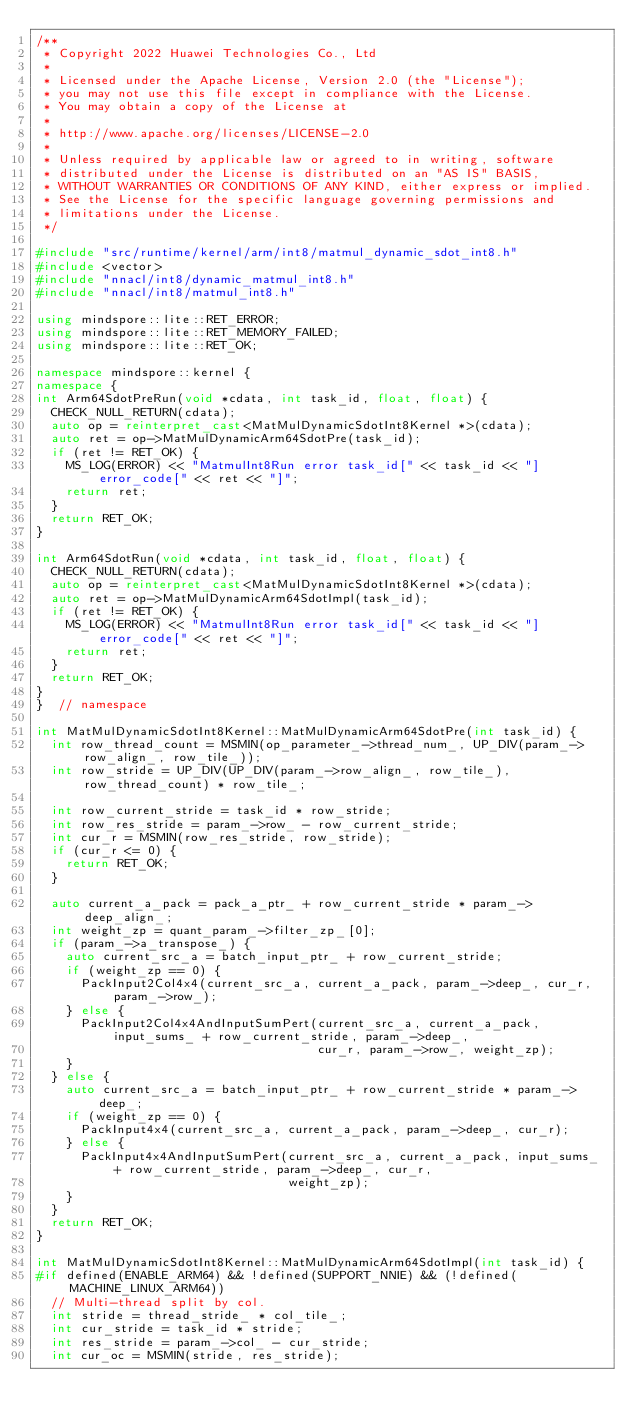Convert code to text. <code><loc_0><loc_0><loc_500><loc_500><_C++_>/**
 * Copyright 2022 Huawei Technologies Co., Ltd
 *
 * Licensed under the Apache License, Version 2.0 (the "License");
 * you may not use this file except in compliance with the License.
 * You may obtain a copy of the License at
 *
 * http://www.apache.org/licenses/LICENSE-2.0
 *
 * Unless required by applicable law or agreed to in writing, software
 * distributed under the License is distributed on an "AS IS" BASIS,
 * WITHOUT WARRANTIES OR CONDITIONS OF ANY KIND, either express or implied.
 * See the License for the specific language governing permissions and
 * limitations under the License.
 */

#include "src/runtime/kernel/arm/int8/matmul_dynamic_sdot_int8.h"
#include <vector>
#include "nnacl/int8/dynamic_matmul_int8.h"
#include "nnacl/int8/matmul_int8.h"

using mindspore::lite::RET_ERROR;
using mindspore::lite::RET_MEMORY_FAILED;
using mindspore::lite::RET_OK;

namespace mindspore::kernel {
namespace {
int Arm64SdotPreRun(void *cdata, int task_id, float, float) {
  CHECK_NULL_RETURN(cdata);
  auto op = reinterpret_cast<MatMulDynamicSdotInt8Kernel *>(cdata);
  auto ret = op->MatMulDynamicArm64SdotPre(task_id);
  if (ret != RET_OK) {
    MS_LOG(ERROR) << "MatmulInt8Run error task_id[" << task_id << "] error_code[" << ret << "]";
    return ret;
  }
  return RET_OK;
}

int Arm64SdotRun(void *cdata, int task_id, float, float) {
  CHECK_NULL_RETURN(cdata);
  auto op = reinterpret_cast<MatMulDynamicSdotInt8Kernel *>(cdata);
  auto ret = op->MatMulDynamicArm64SdotImpl(task_id);
  if (ret != RET_OK) {
    MS_LOG(ERROR) << "MatmulInt8Run error task_id[" << task_id << "] error_code[" << ret << "]";
    return ret;
  }
  return RET_OK;
}
}  // namespace

int MatMulDynamicSdotInt8Kernel::MatMulDynamicArm64SdotPre(int task_id) {
  int row_thread_count = MSMIN(op_parameter_->thread_num_, UP_DIV(param_->row_align_, row_tile_));
  int row_stride = UP_DIV(UP_DIV(param_->row_align_, row_tile_), row_thread_count) * row_tile_;

  int row_current_stride = task_id * row_stride;
  int row_res_stride = param_->row_ - row_current_stride;
  int cur_r = MSMIN(row_res_stride, row_stride);
  if (cur_r <= 0) {
    return RET_OK;
  }

  auto current_a_pack = pack_a_ptr_ + row_current_stride * param_->deep_align_;
  int weight_zp = quant_param_->filter_zp_[0];
  if (param_->a_transpose_) {
    auto current_src_a = batch_input_ptr_ + row_current_stride;
    if (weight_zp == 0) {
      PackInput2Col4x4(current_src_a, current_a_pack, param_->deep_, cur_r, param_->row_);
    } else {
      PackInput2Col4x4AndInputSumPert(current_src_a, current_a_pack, input_sums_ + row_current_stride, param_->deep_,
                                      cur_r, param_->row_, weight_zp);
    }
  } else {
    auto current_src_a = batch_input_ptr_ + row_current_stride * param_->deep_;
    if (weight_zp == 0) {
      PackInput4x4(current_src_a, current_a_pack, param_->deep_, cur_r);
    } else {
      PackInput4x4AndInputSumPert(current_src_a, current_a_pack, input_sums_ + row_current_stride, param_->deep_, cur_r,
                                  weight_zp);
    }
  }
  return RET_OK;
}

int MatMulDynamicSdotInt8Kernel::MatMulDynamicArm64SdotImpl(int task_id) {
#if defined(ENABLE_ARM64) && !defined(SUPPORT_NNIE) && (!defined(MACHINE_LINUX_ARM64))
  // Multi-thread split by col.
  int stride = thread_stride_ * col_tile_;
  int cur_stride = task_id * stride;
  int res_stride = param_->col_ - cur_stride;
  int cur_oc = MSMIN(stride, res_stride);</code> 